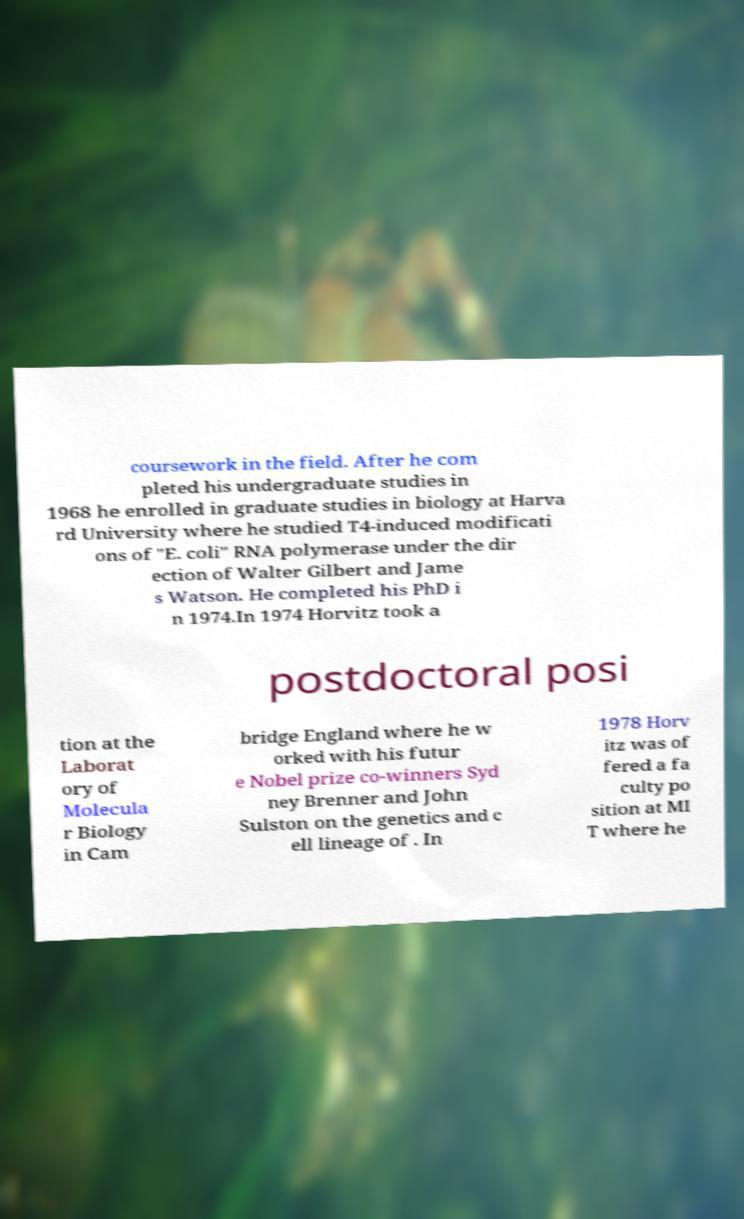I need the written content from this picture converted into text. Can you do that? coursework in the field. After he com pleted his undergraduate studies in 1968 he enrolled in graduate studies in biology at Harva rd University where he studied T4-induced modificati ons of "E. coli" RNA polymerase under the dir ection of Walter Gilbert and Jame s Watson. He completed his PhD i n 1974.In 1974 Horvitz took a postdoctoral posi tion at the Laborat ory of Molecula r Biology in Cam bridge England where he w orked with his futur e Nobel prize co-winners Syd ney Brenner and John Sulston on the genetics and c ell lineage of . In 1978 Horv itz was of fered a fa culty po sition at MI T where he 